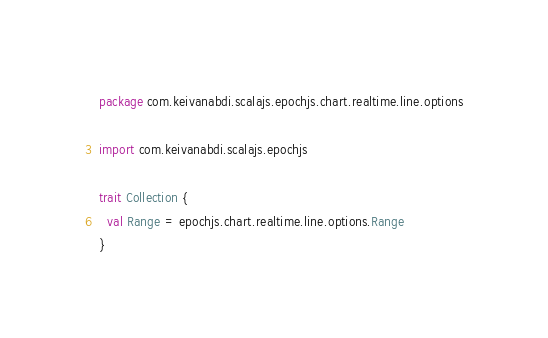<code> <loc_0><loc_0><loc_500><loc_500><_Scala_>package com.keivanabdi.scalajs.epochjs.chart.realtime.line.options

import com.keivanabdi.scalajs.epochjs

trait Collection {
  val Range = epochjs.chart.realtime.line.options.Range
}
</code> 